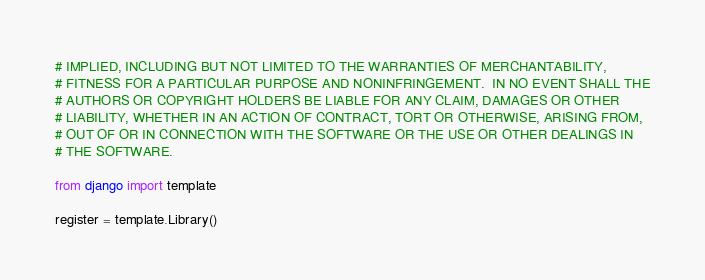<code> <loc_0><loc_0><loc_500><loc_500><_Python_># IMPLIED, INCLUDING BUT NOT LIMITED TO THE WARRANTIES OF MERCHANTABILITY,
# FITNESS FOR A PARTICULAR PURPOSE AND NONINFRINGEMENT.  IN NO EVENT SHALL THE
# AUTHORS OR COPYRIGHT HOLDERS BE LIABLE FOR ANY CLAIM, DAMAGES OR OTHER
# LIABILITY, WHETHER IN AN ACTION OF CONTRACT, TORT OR OTHERWISE, ARISING FROM,
# OUT OF OR IN CONNECTION WITH THE SOFTWARE OR THE USE OR OTHER DEALINGS IN
# THE SOFTWARE.

from django import template

register = template.Library()
</code> 